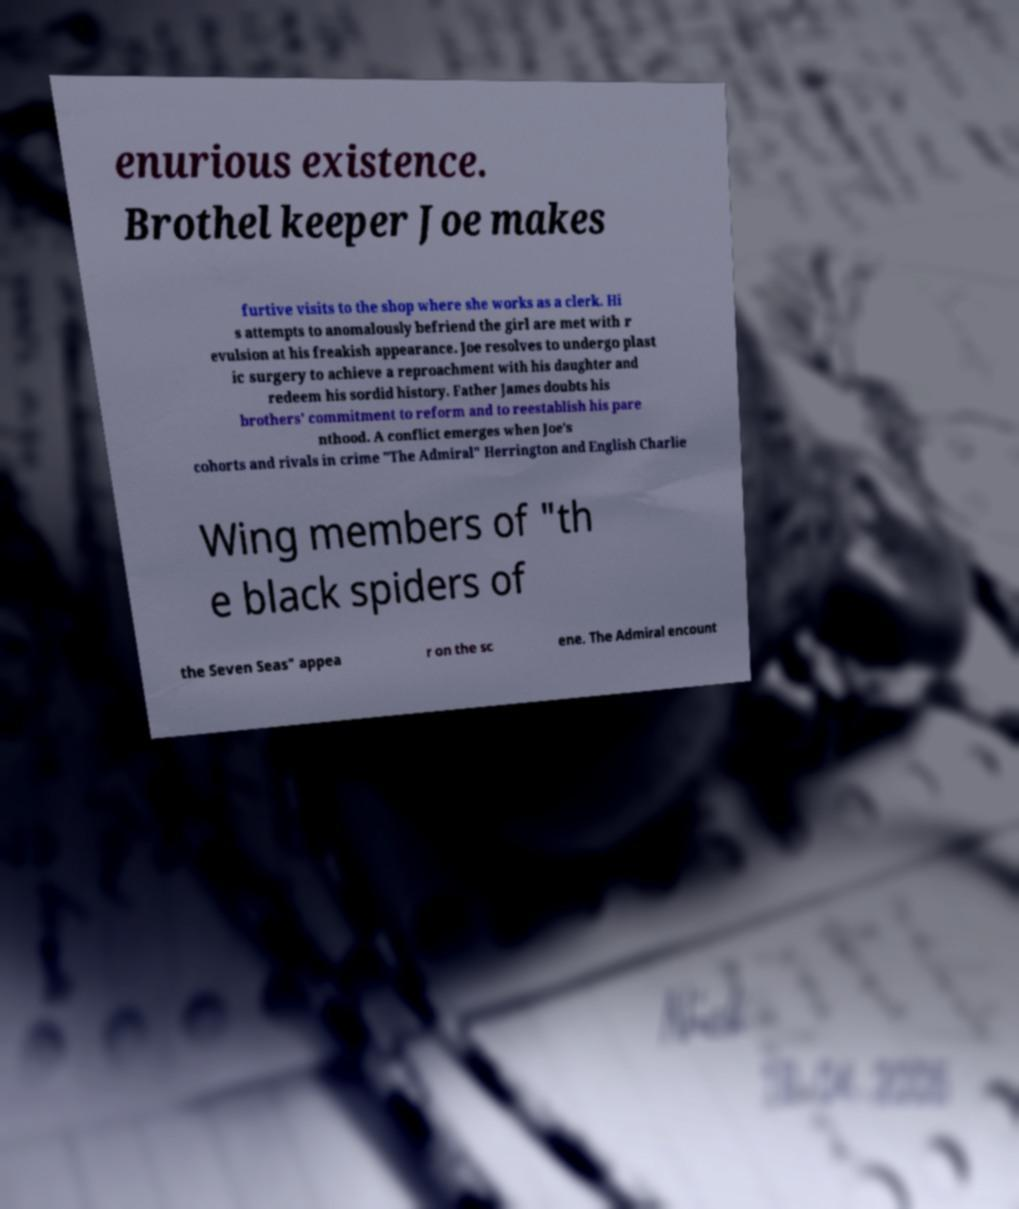Could you extract and type out the text from this image? enurious existence. Brothel keeper Joe makes furtive visits to the shop where she works as a clerk. Hi s attempts to anomalously befriend the girl are met with r evulsion at his freakish appearance. Joe resolves to undergo plast ic surgery to achieve a reproachment with his daughter and redeem his sordid history. Father James doubts his brothers' commitment to reform and to reestablish his pare nthood. A conflict emerges when Joe's cohorts and rivals in crime "The Admiral" Herrington and English Charlie Wing members of "th e black spiders of the Seven Seas" appea r on the sc ene. The Admiral encount 